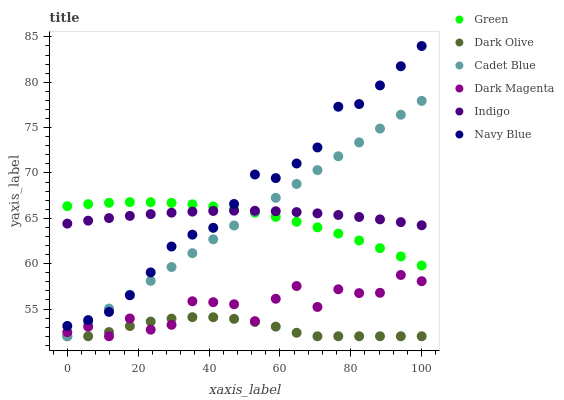Does Dark Olive have the minimum area under the curve?
Answer yes or no. Yes. Does Navy Blue have the maximum area under the curve?
Answer yes or no. Yes. Does Indigo have the minimum area under the curve?
Answer yes or no. No. Does Indigo have the maximum area under the curve?
Answer yes or no. No. Is Cadet Blue the smoothest?
Answer yes or no. Yes. Is Dark Magenta the roughest?
Answer yes or no. Yes. Is Indigo the smoothest?
Answer yes or no. No. Is Indigo the roughest?
Answer yes or no. No. Does Cadet Blue have the lowest value?
Answer yes or no. Yes. Does Indigo have the lowest value?
Answer yes or no. No. Does Navy Blue have the highest value?
Answer yes or no. Yes. Does Indigo have the highest value?
Answer yes or no. No. Is Dark Olive less than Green?
Answer yes or no. Yes. Is Navy Blue greater than Dark Magenta?
Answer yes or no. Yes. Does Green intersect Cadet Blue?
Answer yes or no. Yes. Is Green less than Cadet Blue?
Answer yes or no. No. Is Green greater than Cadet Blue?
Answer yes or no. No. Does Dark Olive intersect Green?
Answer yes or no. No. 